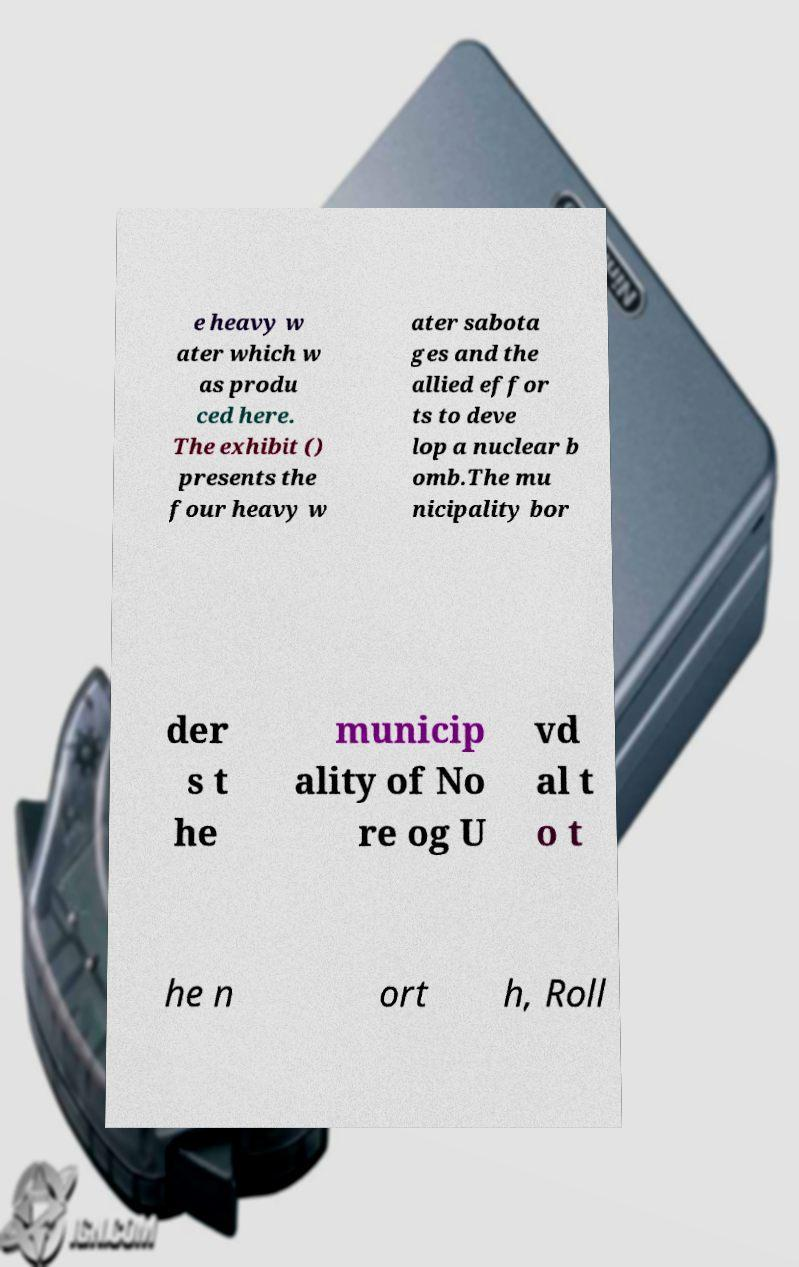What messages or text are displayed in this image? I need them in a readable, typed format. e heavy w ater which w as produ ced here. The exhibit () presents the four heavy w ater sabota ges and the allied effor ts to deve lop a nuclear b omb.The mu nicipality bor der s t he municip ality of No re og U vd al t o t he n ort h, Roll 